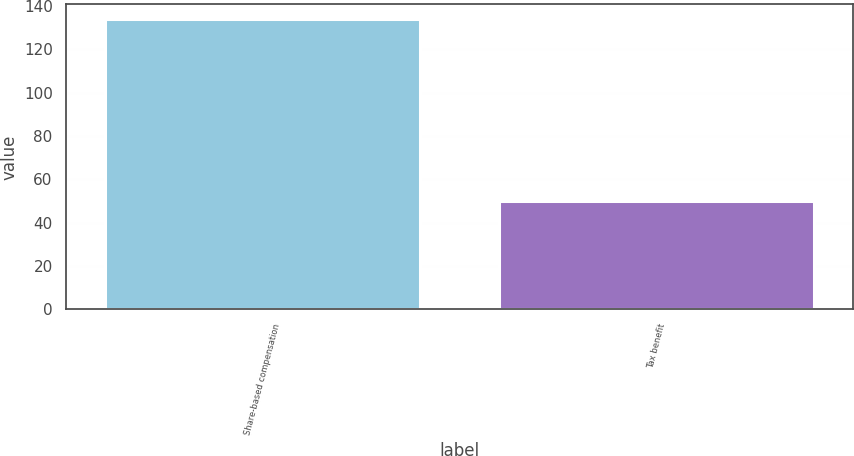<chart> <loc_0><loc_0><loc_500><loc_500><bar_chart><fcel>Share-based compensation<fcel>Tax benefit<nl><fcel>134<fcel>50<nl></chart> 